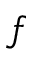<formula> <loc_0><loc_0><loc_500><loc_500>f</formula> 